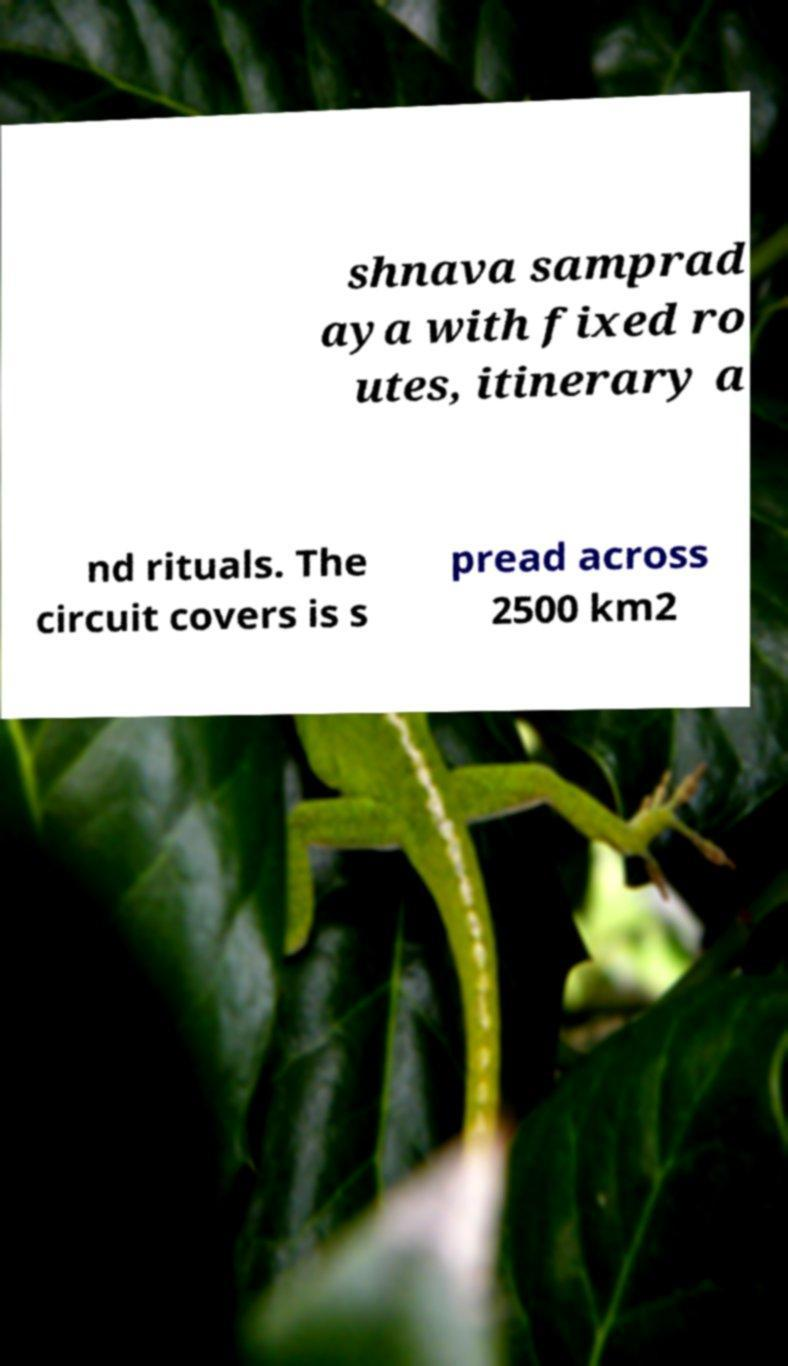I need the written content from this picture converted into text. Can you do that? shnava samprad aya with fixed ro utes, itinerary a nd rituals. The circuit covers is s pread across 2500 km2 